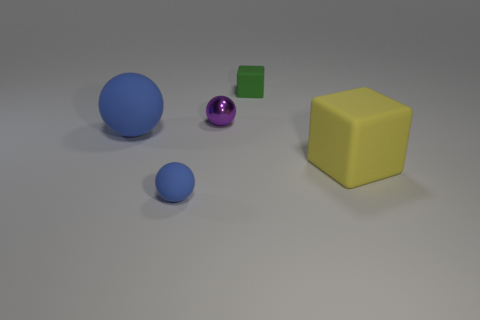Subtract all blue matte spheres. How many spheres are left? 1 Add 4 tiny purple shiny spheres. How many objects exist? 9 Subtract all blocks. How many objects are left? 3 Subtract all purple balls. How many balls are left? 2 Subtract 1 green cubes. How many objects are left? 4 Subtract 1 cubes. How many cubes are left? 1 Subtract all purple blocks. Subtract all red spheres. How many blocks are left? 2 Subtract all cyan cylinders. How many yellow cubes are left? 1 Subtract all blue things. Subtract all green cubes. How many objects are left? 2 Add 5 tiny purple objects. How many tiny purple objects are left? 6 